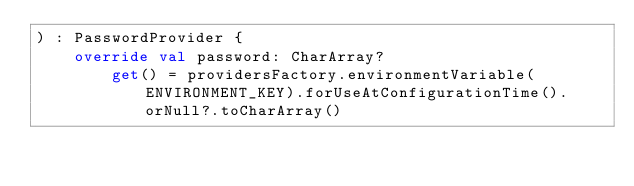<code> <loc_0><loc_0><loc_500><loc_500><_Kotlin_>) : PasswordProvider {
    override val password: CharArray?
        get() = providersFactory.environmentVariable(ENVIRONMENT_KEY).forUseAtConfigurationTime().orNull?.toCharArray()
</code> 